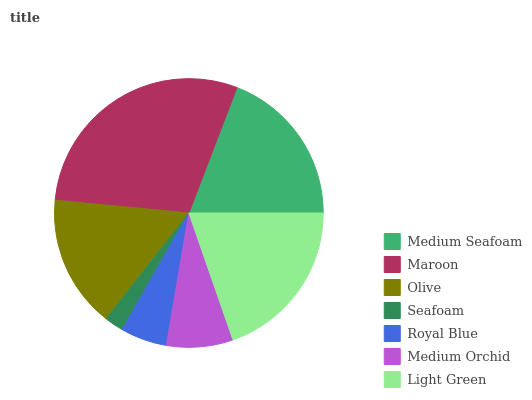Is Seafoam the minimum?
Answer yes or no. Yes. Is Maroon the maximum?
Answer yes or no. Yes. Is Olive the minimum?
Answer yes or no. No. Is Olive the maximum?
Answer yes or no. No. Is Maroon greater than Olive?
Answer yes or no. Yes. Is Olive less than Maroon?
Answer yes or no. Yes. Is Olive greater than Maroon?
Answer yes or no. No. Is Maroon less than Olive?
Answer yes or no. No. Is Olive the high median?
Answer yes or no. Yes. Is Olive the low median?
Answer yes or no. Yes. Is Medium Orchid the high median?
Answer yes or no. No. Is Royal Blue the low median?
Answer yes or no. No. 